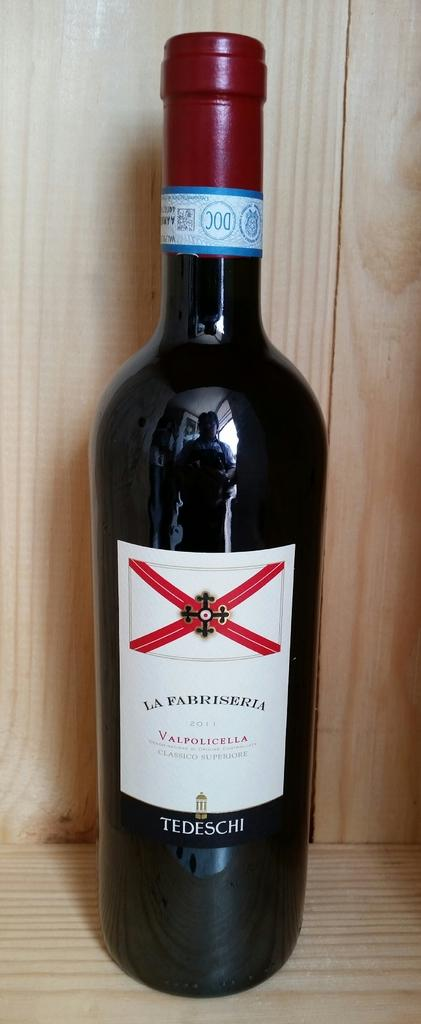<image>
Write a terse but informative summary of the picture. a wine bottle that says Fabriseria on it 